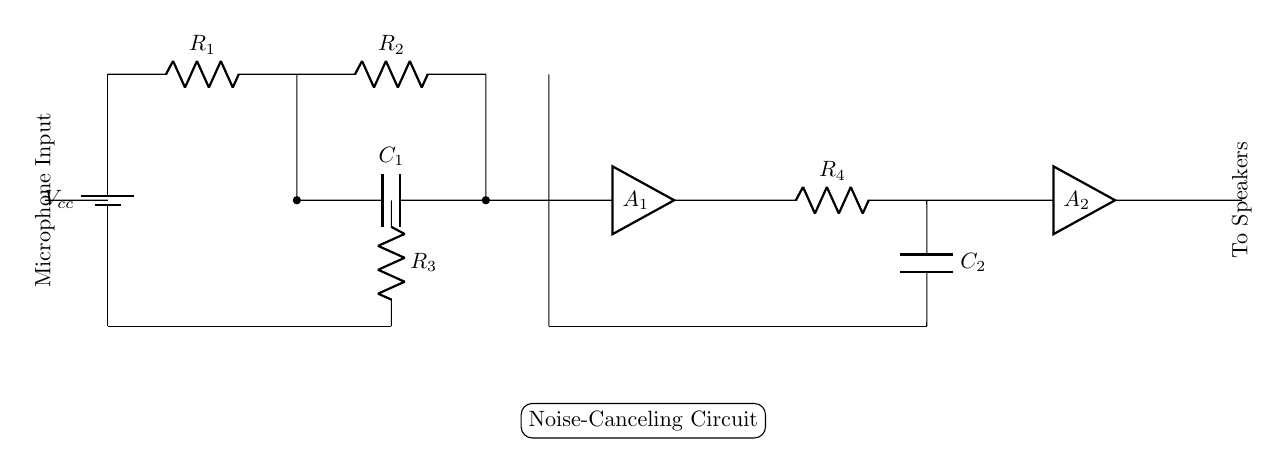What type of circuit is this? This is a noise-canceling circuit specifically designed for use in wireless headphones, indicated by the presence of amplifiers and capacitors aimed at managing audio signals.
Answer: noise-canceling What components are used for filtering? The components used for filtering are the capacitors, labeled as C1 and C2, which are essential in reducing unwanted noise and managing the frequency response of the circuit.
Answer: C1, C2 How many amplifiers are present in this circuit? There are two amplifiers in the circuit, labeled as A1 and A2, which are essential for amplifying the audio signals from the microphones.
Answer: 2 What is the primary input for the circuit? The primary input for the circuit is the microphone input, which captures external sounds that will be processed to cancel out noise.
Answer: Microphone Input How are the resistors configured in this circuit? The resistors are configured in series between the power supply and the capacitors, which helps in controlling the current and voltage levels throughout the circuit.
Answer: Series configuration What is the role of capacitors in this circuit? The capacitors serve as filtering elements that smooth out voltage fluctuations and reduce noise, enhancing the audio quality sent to the speakers.
Answer: Filtering 